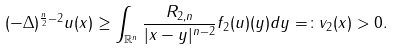Convert formula to latex. <formula><loc_0><loc_0><loc_500><loc_500>( - \Delta ) ^ { \frac { n } { 2 } - 2 } u ( x ) \geq \int _ { \mathbb { R } ^ { n } } \frac { R _ { 2 , n } } { | x - y | ^ { n - 2 } } f _ { 2 } ( u ) ( y ) d y = \colon v _ { 2 } ( x ) > 0 .</formula> 